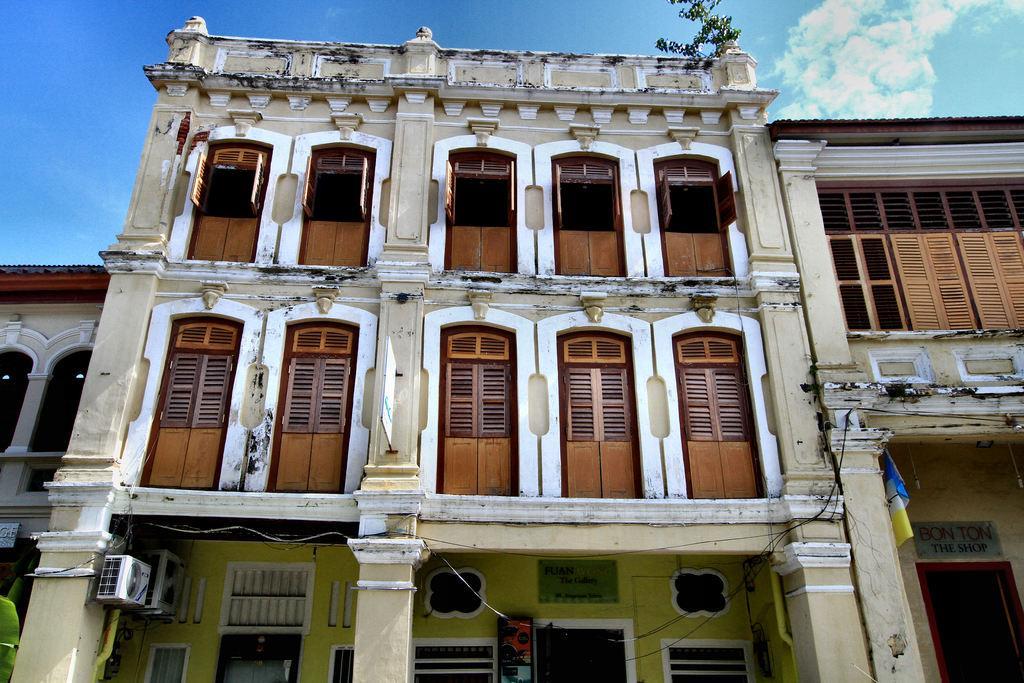Describe this image in one or two sentences. In this image I can see a building and on the right side of this image I can see a colourful cloth. On the bottom side I can see few boards and on these words I can see something is written. On the bottom left side and on the top of this building I can see few plants. I can also see clouds and the sky on the top side of this image. 